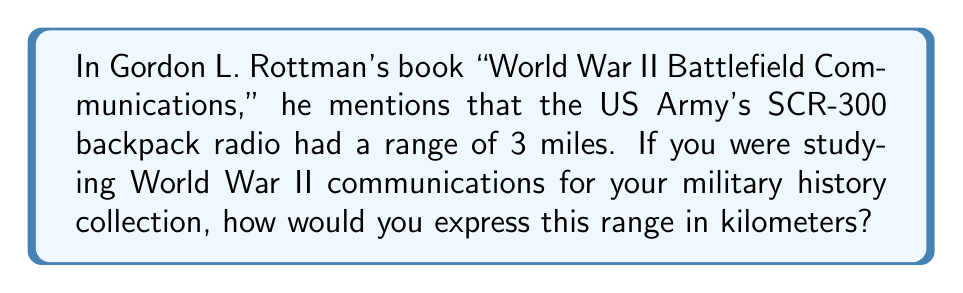Give your solution to this math problem. To convert miles to kilometers, we need to follow these steps:

1. Recall the conversion factor: 1 mile ≈ 1.60934 kilometers

2. Set up the conversion equation:
   $$ 3 \text{ miles} \times \frac{1.60934 \text{ km}}{1 \text{ mile}} = x \text{ km} $$

3. Multiply:
   $$ x = 3 \times 1.60934 = 4.82802 \text{ km} $$

4. Round to two decimal places for practical use:
   $$ x \approx 4.83 \text{ km} $$

Therefore, the 3-mile range of the SCR-300 radio is approximately 4.83 kilometers.
Answer: 4.83 km 